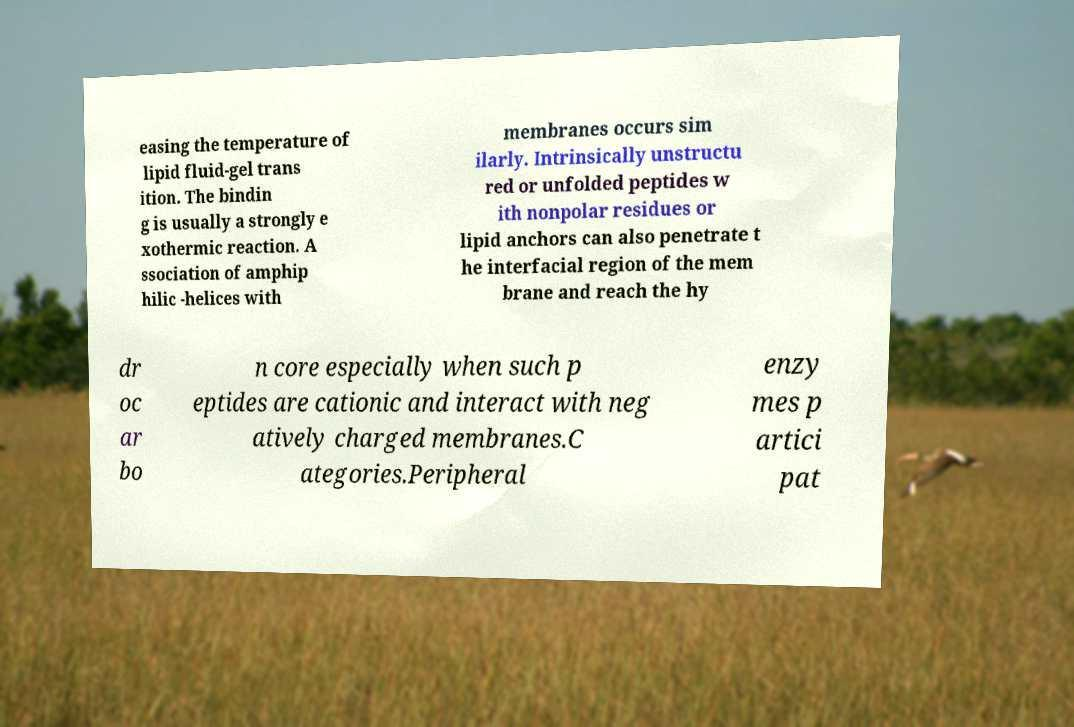What messages or text are displayed in this image? I need them in a readable, typed format. easing the temperature of lipid fluid-gel trans ition. The bindin g is usually a strongly e xothermic reaction. A ssociation of amphip hilic -helices with membranes occurs sim ilarly. Intrinsically unstructu red or unfolded peptides w ith nonpolar residues or lipid anchors can also penetrate t he interfacial region of the mem brane and reach the hy dr oc ar bo n core especially when such p eptides are cationic and interact with neg atively charged membranes.C ategories.Peripheral enzy mes p artici pat 